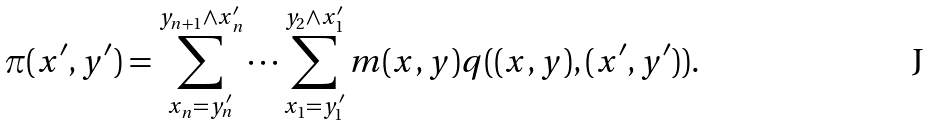Convert formula to latex. <formula><loc_0><loc_0><loc_500><loc_500>\pi ( x ^ { \prime } , y ^ { \prime } ) = \sum _ { x _ { n } = y _ { n } ^ { \prime } } ^ { y _ { n + 1 } \wedge x _ { n } ^ { \prime } } \dots \sum _ { x _ { 1 } = y _ { 1 } ^ { \prime } } ^ { y _ { 2 } \wedge x _ { 1 } ^ { \prime } } m ( x , y ) q ( ( x , y ) , ( x ^ { \prime } , y ^ { \prime } ) ) .</formula> 